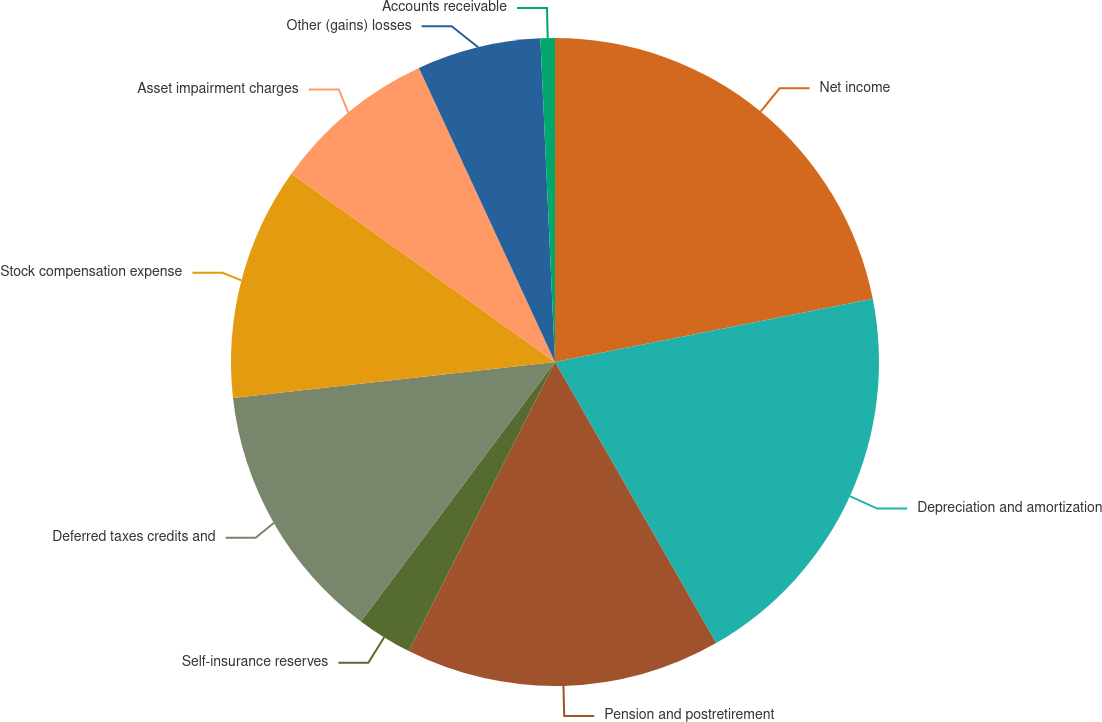Convert chart. <chart><loc_0><loc_0><loc_500><loc_500><pie_chart><fcel>Net income<fcel>Depreciation and amortization<fcel>Pension and postretirement<fcel>Self-insurance reserves<fcel>Deferred taxes credits and<fcel>Stock compensation expense<fcel>Asset impairment charges<fcel>Other (gains) losses<fcel>Accounts receivable<nl><fcel>21.88%<fcel>19.84%<fcel>15.74%<fcel>2.77%<fcel>13.01%<fcel>11.64%<fcel>8.23%<fcel>6.18%<fcel>0.72%<nl></chart> 